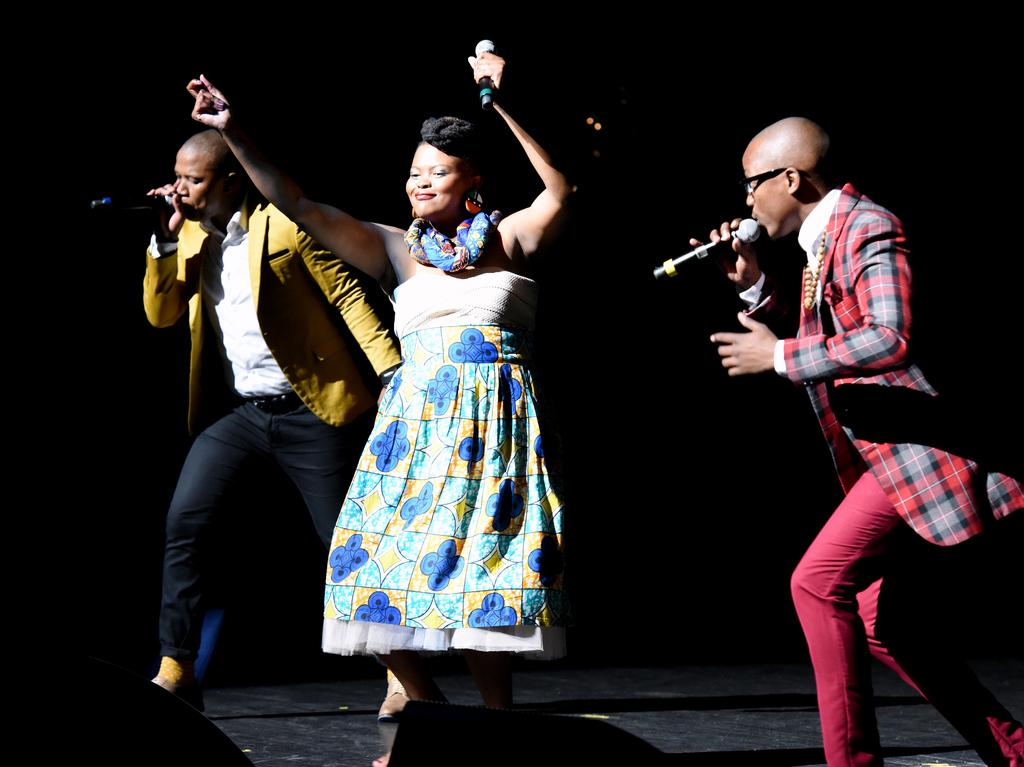How many people are in the image? There are three persons in the image. What are the persons doing in the image? The persons are standing and holding microphones. What can be observed about the background of the image? The background of the image is dark. What type of oven can be seen in the image? There is no oven present in the image. Can you describe the carriage in the image? There is no carriage present in the image. 